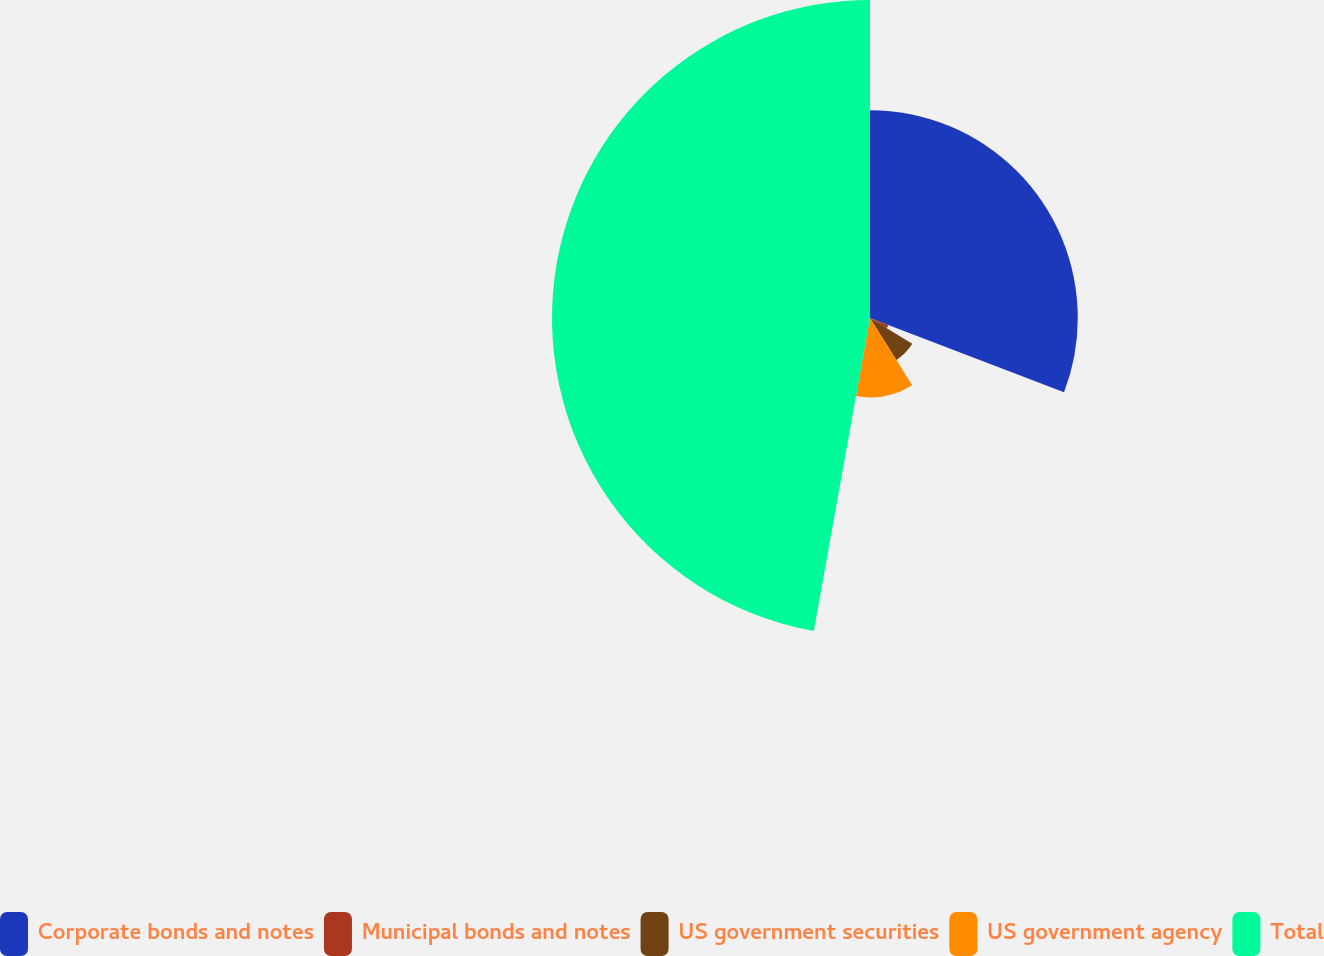Convert chart to OTSL. <chart><loc_0><loc_0><loc_500><loc_500><pie_chart><fcel>Corporate bonds and notes<fcel>Municipal bonds and notes<fcel>US government securities<fcel>US government agency<fcel>Total<nl><fcel>30.82%<fcel>2.91%<fcel>7.34%<fcel>11.76%<fcel>47.17%<nl></chart> 